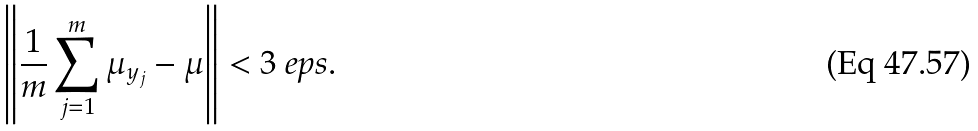<formula> <loc_0><loc_0><loc_500><loc_500>\left \| \frac { 1 } { m } \sum _ { j = 1 } ^ { m } \mu _ { y _ { j } } - \mu \right \| < 3 \ e p s .</formula> 